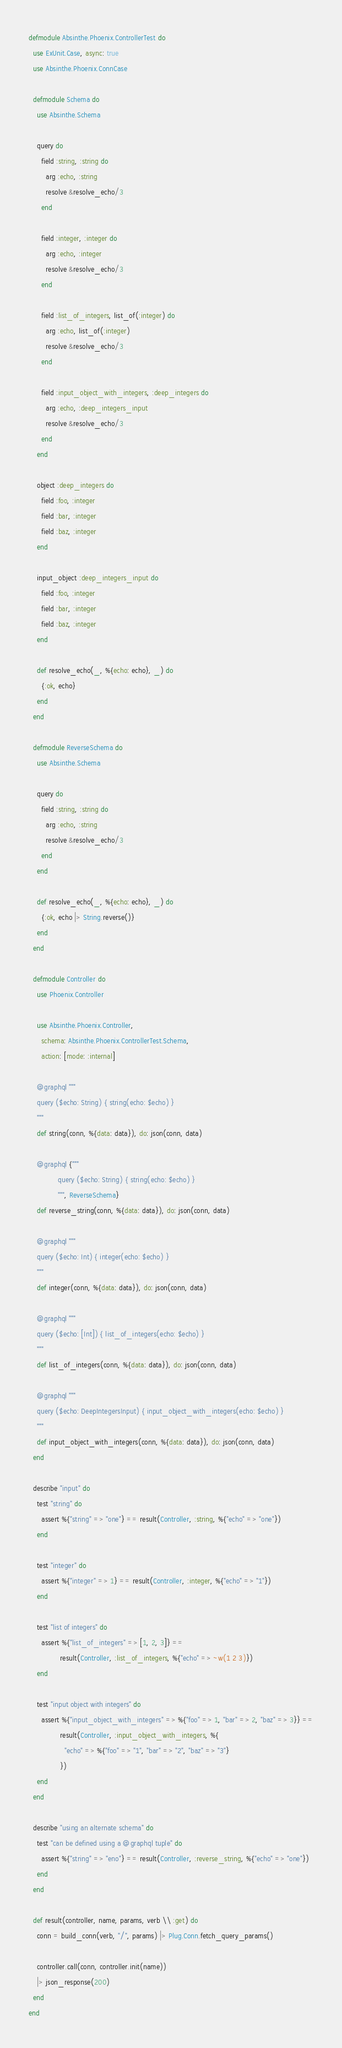Convert code to text. <code><loc_0><loc_0><loc_500><loc_500><_Elixir_>defmodule Absinthe.Phoenix.ControllerTest do
  use ExUnit.Case, async: true
  use Absinthe.Phoenix.ConnCase

  defmodule Schema do
    use Absinthe.Schema

    query do
      field :string, :string do
        arg :echo, :string
        resolve &resolve_echo/3
      end

      field :integer, :integer do
        arg :echo, :integer
        resolve &resolve_echo/3
      end

      field :list_of_integers, list_of(:integer) do
        arg :echo, list_of(:integer)
        resolve &resolve_echo/3
      end

      field :input_object_with_integers, :deep_integers do
        arg :echo, :deep_integers_input
        resolve &resolve_echo/3
      end
    end

    object :deep_integers do
      field :foo, :integer
      field :bar, :integer
      field :baz, :integer
    end

    input_object :deep_integers_input do
      field :foo, :integer
      field :bar, :integer
      field :baz, :integer
    end

    def resolve_echo(_, %{echo: echo}, _) do
      {:ok, echo}
    end
  end

  defmodule ReverseSchema do
    use Absinthe.Schema

    query do
      field :string, :string do
        arg :echo, :string
        resolve &resolve_echo/3
      end
    end

    def resolve_echo(_, %{echo: echo}, _) do
      {:ok, echo |> String.reverse()}
    end
  end

  defmodule Controller do
    use Phoenix.Controller

    use Absinthe.Phoenix.Controller,
      schema: Absinthe.Phoenix.ControllerTest.Schema,
      action: [mode: :internal]

    @graphql """
    query ($echo: String) { string(echo: $echo) }
    """
    def string(conn, %{data: data}), do: json(conn, data)

    @graphql {"""
              query ($echo: String) { string(echo: $echo) }
              """, ReverseSchema}
    def reverse_string(conn, %{data: data}), do: json(conn, data)

    @graphql """
    query ($echo: Int) { integer(echo: $echo) }
    """
    def integer(conn, %{data: data}), do: json(conn, data)

    @graphql """
    query ($echo: [Int]) { list_of_integers(echo: $echo) }
    """
    def list_of_integers(conn, %{data: data}), do: json(conn, data)

    @graphql """
    query ($echo: DeepIntegersInput) { input_object_with_integers(echo: $echo) }
    """
    def input_object_with_integers(conn, %{data: data}), do: json(conn, data)
  end

  describe "input" do
    test "string" do
      assert %{"string" => "one"} == result(Controller, :string, %{"echo" => "one"})
    end

    test "integer" do
      assert %{"integer" => 1} == result(Controller, :integer, %{"echo" => "1"})
    end

    test "list of integers" do
      assert %{"list_of_integers" => [1, 2, 3]} ==
               result(Controller, :list_of_integers, %{"echo" => ~w(1 2 3)})
    end

    test "input object with integers" do
      assert %{"input_object_with_integers" => %{"foo" => 1, "bar" => 2, "baz" => 3}} ==
               result(Controller, :input_object_with_integers, %{
                 "echo" => %{"foo" => "1", "bar" => "2", "baz" => "3"}
               })
    end
  end

  describe "using an alternate schema" do
    test "can be defined using a @graphql tuple" do
      assert %{"string" => "eno"} == result(Controller, :reverse_string, %{"echo" => "one"})
    end
  end

  def result(controller, name, params, verb \\ :get) do
    conn = build_conn(verb, "/", params) |> Plug.Conn.fetch_query_params()

    controller.call(conn, controller.init(name))
    |> json_response(200)
  end
end
</code> 